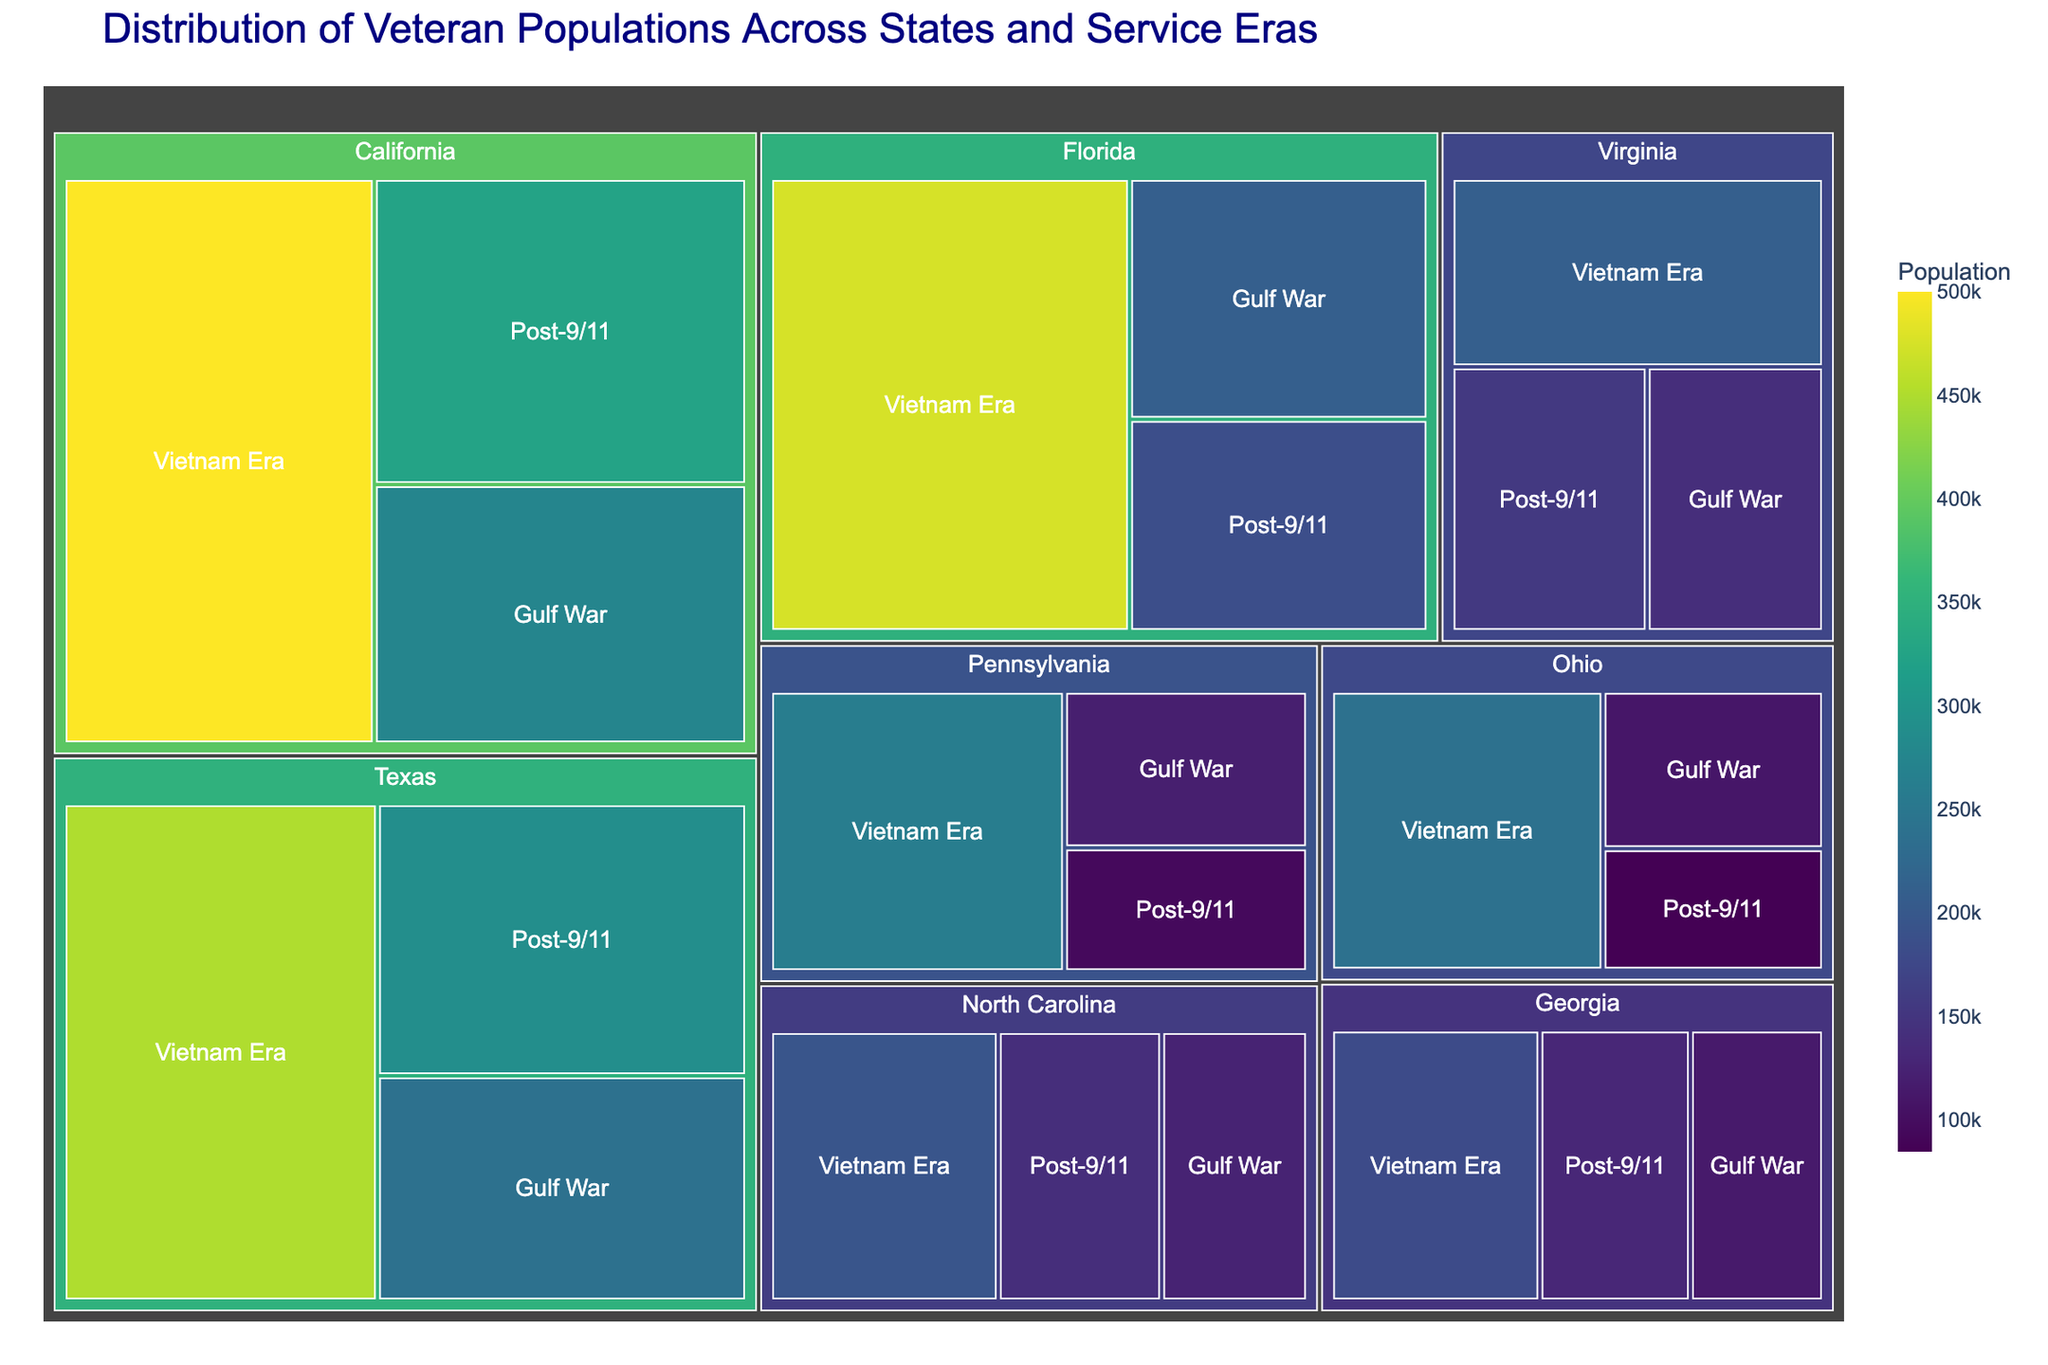What is the title of the treemap? The title is usually found at the top of the treemap. The title of this treemap is 'Distribution of Veteran Populations Across States and Service Eras'.
Answer: Distribution of Veteran Populations Across States and Service Eras Which state has the highest population of Post-9/11 veterans? By looking at the treemap, we can identify which state has the largest segment for Post-9/11 veterans. California's segment is the largest for Post-9/11 veterans with a population of 325,000.
Answer: California What is the total population of veterans in Texas? We need to sum up the populations of all service eras in Texas. For Texas: Post-9/11 (290,000) + Vietnam Era (450,000) + Gulf War (240,000) = 980,000.
Answer: 980,000 Which state has a higher population of Vietnam Era veterans, Florida or Pennsylvania? We compare the segments for Vietnam Era veterans in both states based on the sizes or the numbers. Florida has 475,000 Vietnam Era veterans whereas Pennsylvania has 260,000.
Answer: Florida Which service era has the lowest veteran population in Ohio? By analyzing the segments for Ohio, we find that the Post-9/11 era has the lowest veteran population with 85,000 compared to Vietnam Era and Gulf War.
Answer: Post-9/11 Arrange the states in descending order based on their total veteran population. To determine this, we sum the populations of all service eras for each state and sort them. 
1. California: 1,100,000 
2. Texas: 980,000 
3. Florida: 870,000 
4. Pennsylvania: 475,000 
5. Ohio: 435,000 
6. Virginia: 505,000 
7. North Carolina: 460,000 
8. Georgia: 425,000
Answer: California, Texas, Florida, Virginia, Pennsylvania, North Carolina, Ohio, Georgia What is the total population of Gulf War veterans across all states? We need to sum up the Gulf War veteran populations from all states. For Gulf War:
California (275,000) + Texas (240,000) + Florida (210,000) + Pennsylvania (120,000) + Ohio (110,000) + Virginia (140,000) + North Carolina (125,000) + Georgia (115,000) = 1,335,000.
Answer: 1,335,000 Which state has a greater population of Vietnam Era veterans, Ohio or Virginia? We observe the segments for Vietnam Era veterans in both states. Ohio has 240,000 and Virginia has 210,000, so Ohio has a greater population.
Answer: Ohio What is the population difference between Post-9/11 veterans in California and Texas? We subtract the population of Post-9/11 veterans in Texas from that in California. 325,000 (California) - 290,000 (Texas) = 35,000.
Answer: 35,000 Which service era has the largest segment in the treemap? By examining the various segments across states, the largest single segment is for Vietnam Era veterans in California with a population of 500,000.
Answer: Vietnam Era veterans in California 